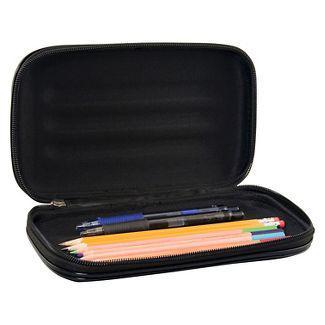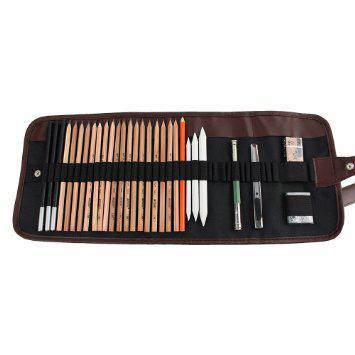The first image is the image on the left, the second image is the image on the right. For the images displayed, is the sentence "Some of the cases contain long yellow pencils." factually correct? Answer yes or no. Yes. 